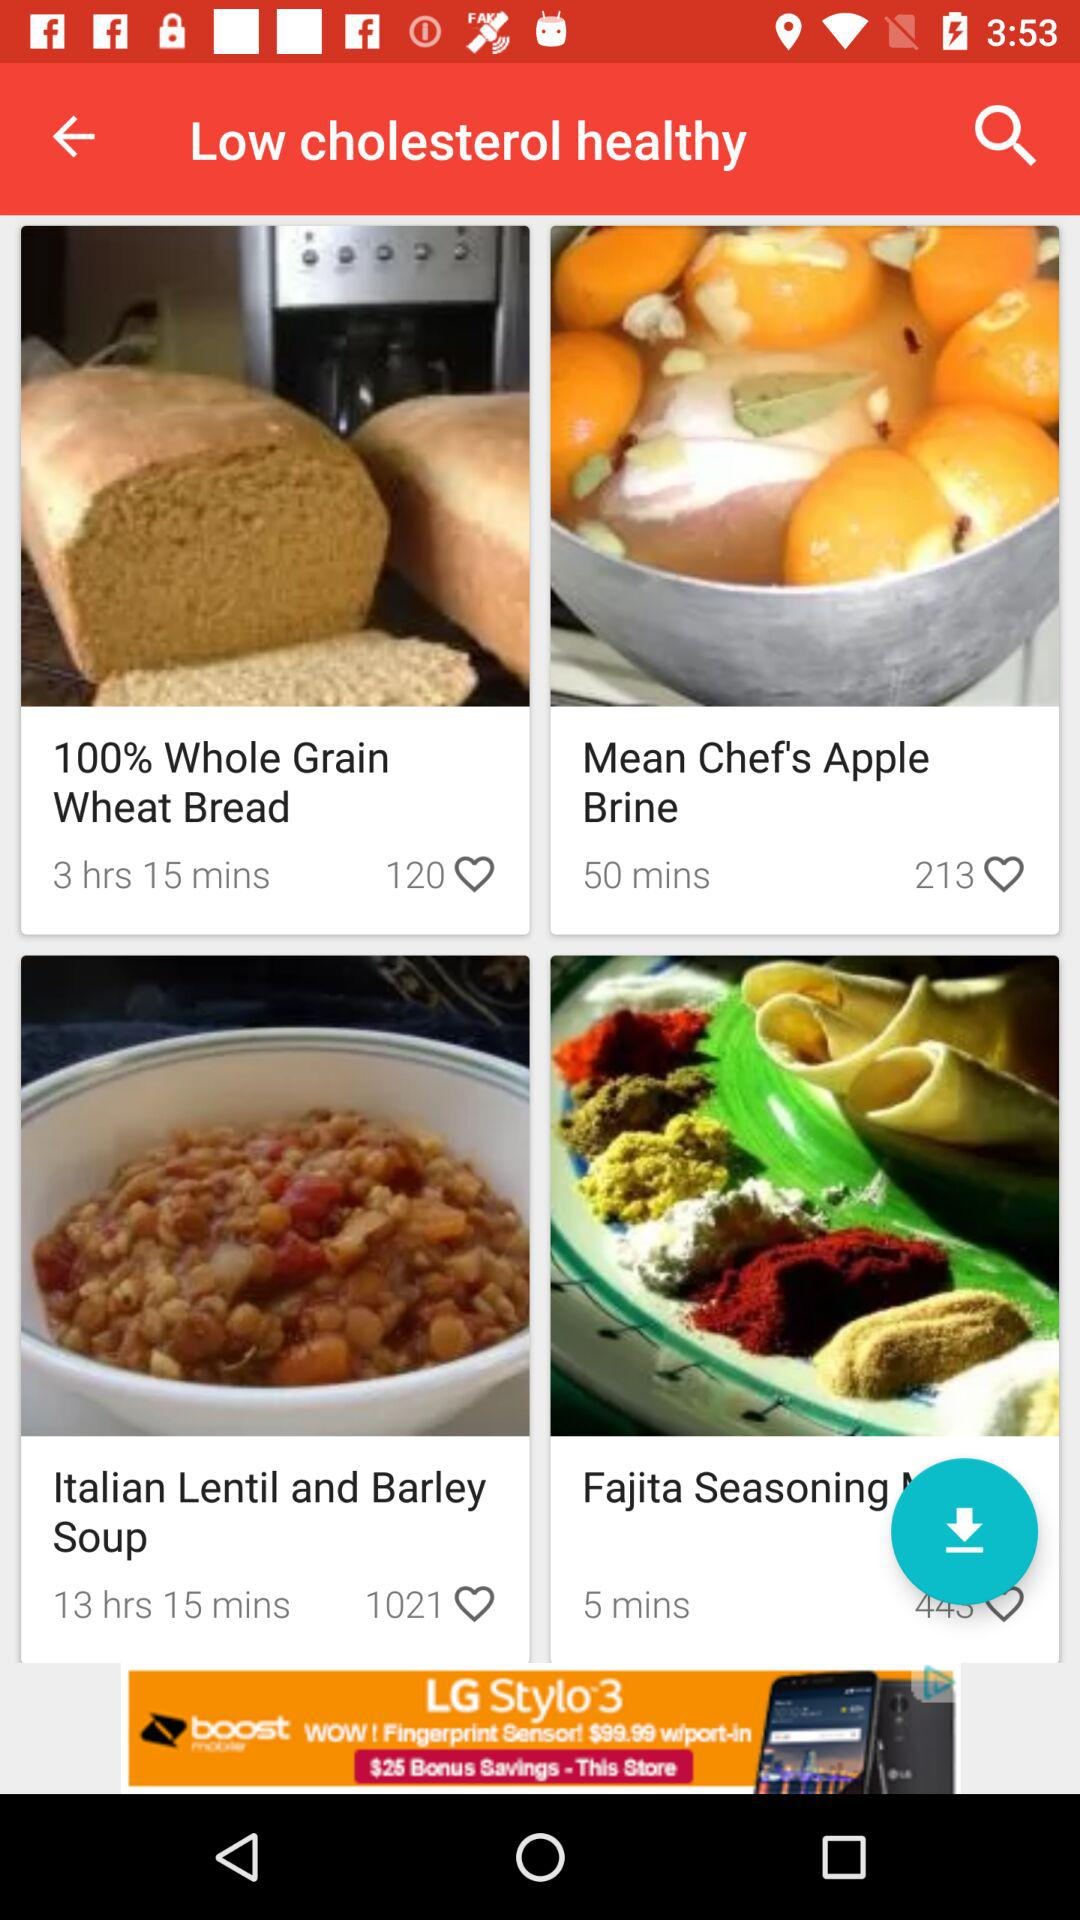What is the number of likes for Italian Lentil and Barley Soup? The number of likes is 1021. 